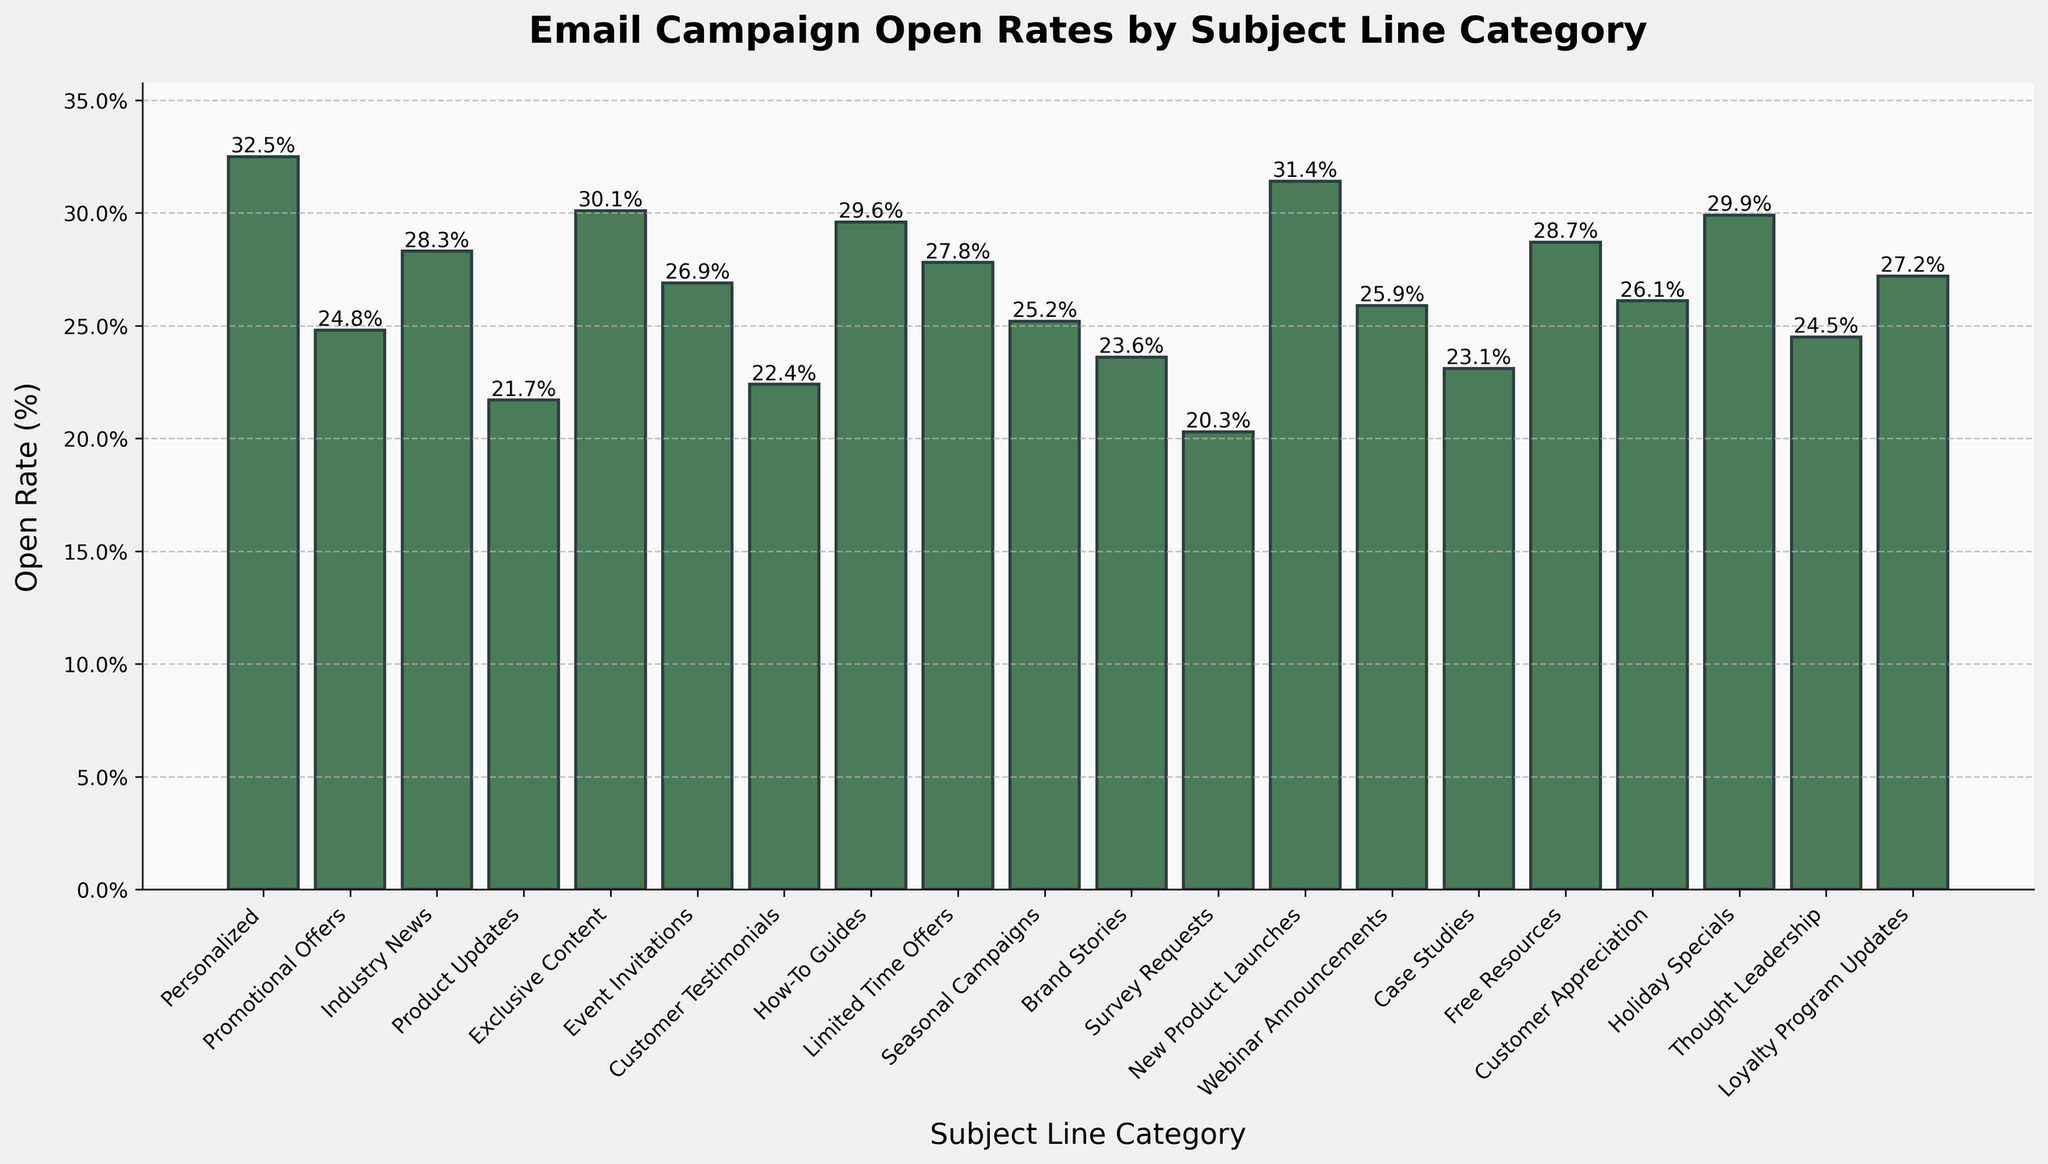Which subject line category has the highest open rate? Find the tallest bar in the chart, which represents the highest open rate. The tallest bar corresponds to the "Personalized" category with an open rate of 32.5%.
Answer: Personalized Which two subject line categories have the lowest open rates? Identify the two shortest bars in the chart, which correspond to the lowest open rates. The shortest bars are for "Survey Requests" with an open rate of 20.3% and "Product Updates" with an open rate of 21.7%.
Answer: Survey Requests and Product Updates What is the average open rate across all subject line categories? Sum all the open rates and divide by the number of categories: (32.5 + 24.8 + 28.3 + 21.7 + 30.1 + 26.9 + 22.4 + 29.6 + 27.8 + 25.2 + 23.6 + 20.3 + 31.4 + 25.9 + 23.1 + 28.7 + 26.1 + 29.9 + 24.5 + 27.2) / 20 = 26.54%.
Answer: 26.54% Which subject line category has a higher open rate, "Exclusive Content" or "Thought Leadership"? Compare the bar lengths of "Exclusive Content" and "Thought Leadership". "Exclusive Content" has an open rate of 30.1%, while "Thought Leadership" has an open rate of 24.5%. Therefore, "Exclusive Content" has a higher open rate.
Answer: Exclusive Content How much higher is the open rate for "New Product Launches" compared to "Brand Stories"? Subtract the open rate of "Brand Stories" from "New Product Launches": 31.4% - 23.6% = 7.8%.
Answer: 7.8% What is the difference in open rates between the "Holiday Specials" and the "Event Invitations" categories? Subtract the open rate of "Event Invitations" from "Holiday Specials": 29.9% - 26.9% = 3.0%.
Answer: 3.0% Which category falls exactly in the middle in terms of open rate (median category)? Sort the open rates and find the middle value. The sorted open rates are: 20.3, 21.7, 22.4, 23.1, 23.6, 24.5, 24.8, 25.2, 25.9, 26.1, 26.9, 27.2, 27.8, 28.3, 28.7, 29.6, 29.9, 30.1, 31.4, 32.5. The median value (10th and 11th) are 26.1 and 26.9, corresponding to "Customer Appreciation" and "Event Invitations".
Answer: Customer Appreciation and Event Invitations What is the combined open rate of "Personalized" and "New Product Launches" categories? Add the open rates of "Personalized" and "New Product Launches": 32.5% + 31.4% = 63.9%.
Answer: 63.9% 